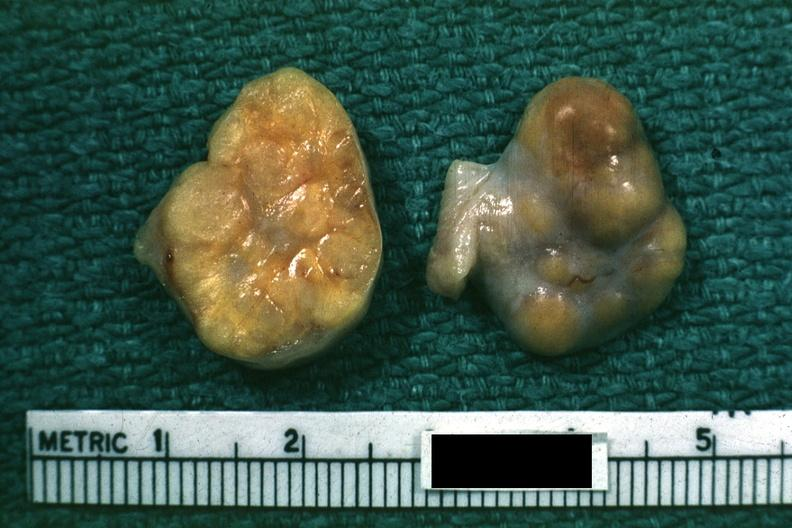s intraductal papillomatosis with apocrine metaplasia present?
Answer the question using a single word or phrase. No 